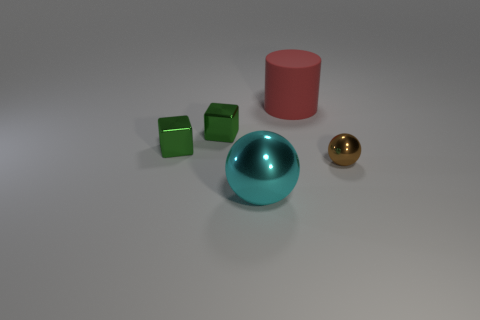How many objects are there in total within the image? There are four objects visible in the image: two green cubes, one pink cylinder, one cyan shiny sphere, and a small golden sphere.  Can you tell me about the material of the objects? Certainly! The green cubes and the pink cylinder appear to have a matte finish, suggesting they might be made of a plastic or rubber material. The cyan object has a reflective, shiny surface, indicative of a metallic or glass material, while the small sphere on the right has a golden color and a glossy finish, also suggesting a metallic nature. 